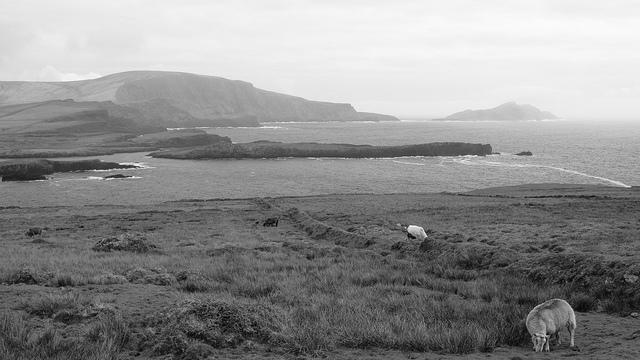What kind of an area is this? Please explain your reasoning. coastal. The area is coastal. 